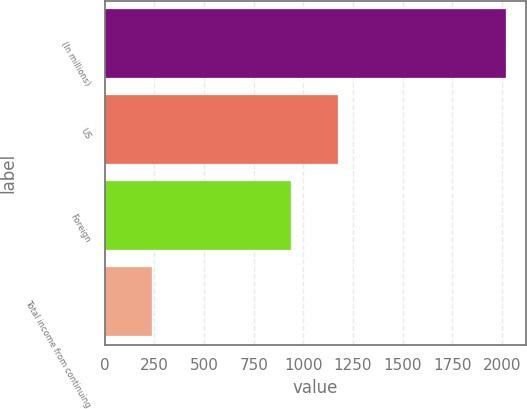<chart> <loc_0><loc_0><loc_500><loc_500><bar_chart><fcel>(In millions)<fcel>US<fcel>Foreign<fcel>Total income from continuing<nl><fcel>2018<fcel>1175<fcel>936<fcel>239<nl></chart> 